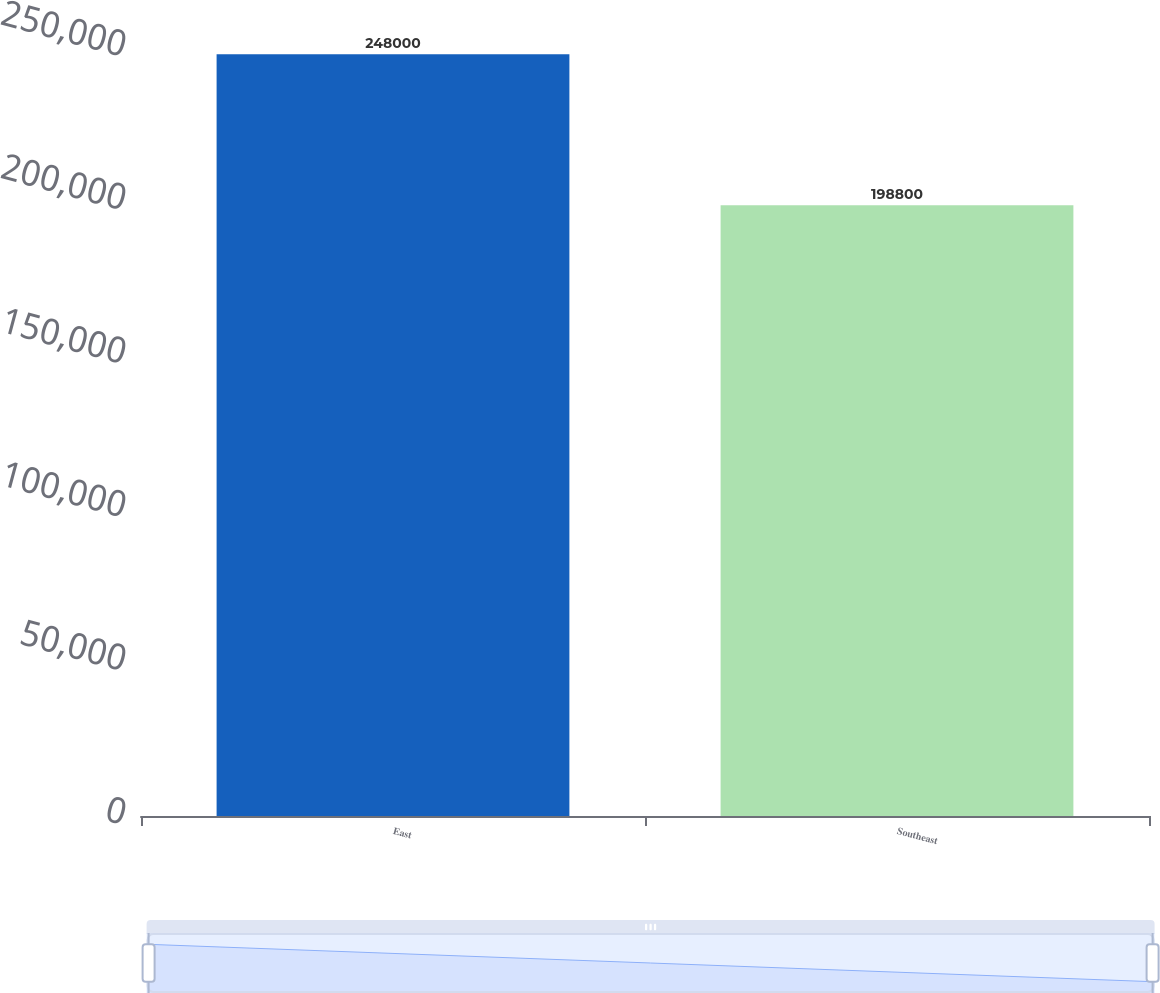Convert chart to OTSL. <chart><loc_0><loc_0><loc_500><loc_500><bar_chart><fcel>East<fcel>Southeast<nl><fcel>248000<fcel>198800<nl></chart> 